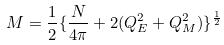Convert formula to latex. <formula><loc_0><loc_0><loc_500><loc_500>M = \frac { 1 } { 2 } \{ \frac { N } { 4 \pi } + 2 ( Q _ { E } ^ { 2 } + Q _ { M } ^ { 2 } ) \} ^ { \frac { 1 } { 2 } }</formula> 